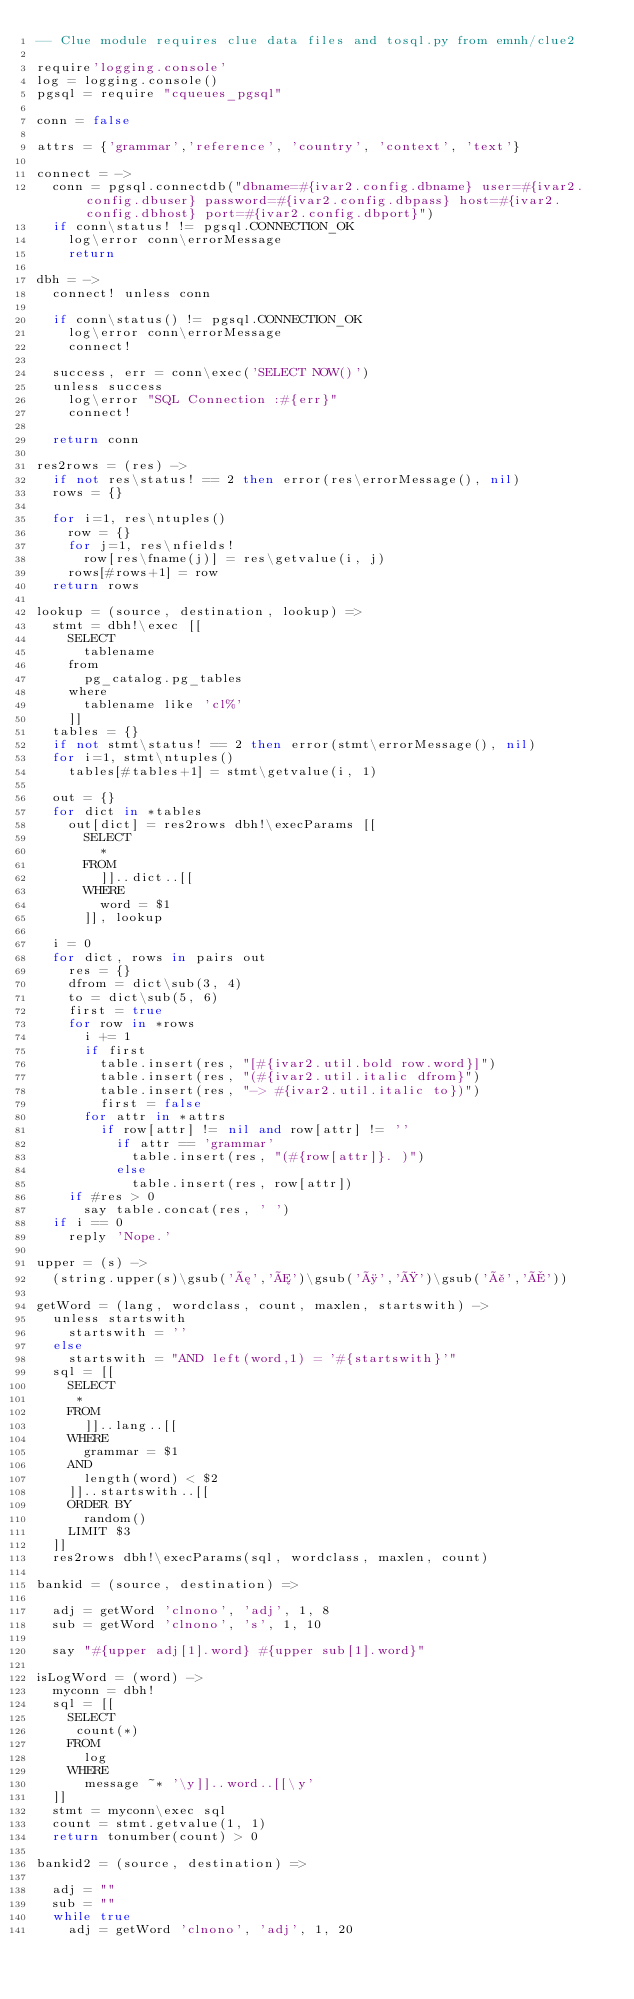Convert code to text. <code><loc_0><loc_0><loc_500><loc_500><_MoonScript_>-- Clue module requires clue data files and tosql.py from emnh/clue2

require'logging.console'
log = logging.console()
pgsql = require "cqueues_pgsql"

conn = false

attrs = {'grammar','reference', 'country', 'context', 'text'}

connect = ->
  conn = pgsql.connectdb("dbname=#{ivar2.config.dbname} user=#{ivar2.config.dbuser} password=#{ivar2.config.dbpass} host=#{ivar2.config.dbhost} port=#{ivar2.config.dbport}")
  if conn\status! != pgsql.CONNECTION_OK
    log\error conn\errorMessage
    return

dbh = ->
  connect! unless conn

  if conn\status() != pgsql.CONNECTION_OK
    log\error conn\errorMessage
    connect!

  success, err = conn\exec('SELECT NOW()')
  unless success
    log\error "SQL Connection :#{err}"
    connect!

  return conn

res2rows = (res) ->
  if not res\status! == 2 then error(res\errorMessage(), nil)
  rows = {}

  for i=1, res\ntuples()
    row = {}
    for j=1, res\nfields!
      row[res\fname(j)] = res\getvalue(i, j)
    rows[#rows+1] = row
  return rows

lookup = (source, destination, lookup) =>
  stmt = dbh!\exec [[
    SELECT
      tablename
    from
      pg_catalog.pg_tables
    where
      tablename like 'cl%'
    ]]
  tables = {}
  if not stmt\status! == 2 then error(stmt\errorMessage(), nil)
  for i=1, stmt\ntuples()
    tables[#tables+1] = stmt\getvalue(i, 1)

  out = {}
  for dict in *tables
    out[dict] = res2rows dbh!\execParams [[
      SELECT
        *
      FROM
        ]]..dict..[[
      WHERE
        word = $1
      ]], lookup

  i = 0
  for dict, rows in pairs out
    res = {}
    dfrom = dict\sub(3, 4)
    to = dict\sub(5, 6)
    first = true
    for row in *rows
      i += 1
      if first
        table.insert(res, "[#{ivar2.util.bold row.word}]")
        table.insert(res, "(#{ivar2.util.italic dfrom}")
        table.insert(res, "-> #{ivar2.util.italic to})")
        first = false
      for attr in *attrs
        if row[attr] != nil and row[attr] != ''
          if attr == 'grammar'
            table.insert(res, "(#{row[attr]}. )")
          else
            table.insert(res, row[attr])
    if #res > 0
      say table.concat(res, ' ')
  if i == 0
    reply 'Nope.'

upper = (s) ->
  (string.upper(s)\gsub('æ','Æ')\gsub('ø','Ø')\gsub('å','Å'))

getWord = (lang, wordclass, count, maxlen, startswith) ->
  unless startswith
    startswith = ''
  else
    startswith = "AND left(word,1) = '#{startswith}'"
  sql = [[
    SELECT
     *
    FROM
      ]]..lang..[[
    WHERE
      grammar = $1
    AND
      length(word) < $2
    ]]..startswith..[[
    ORDER BY
      random()
    LIMIT $3
  ]]
  res2rows dbh!\execParams(sql, wordclass, maxlen, count)

bankid = (source, destination) =>

  adj = getWord 'clnono', 'adj', 1, 8
  sub = getWord 'clnono', 's', 1, 10

  say "#{upper adj[1].word} #{upper sub[1].word}"

isLogWord = (word) ->
  myconn = dbh!
  sql = [[
    SELECT
     count(*)
    FROM
      log
    WHERE
      message ~* '\y]]..word..[[\y'
  ]]
  stmt = myconn\exec sql
  count = stmt.getvalue(1, 1)
  return tonumber(count) > 0

bankid2 = (source, destination) =>

  adj = ""
  sub = ""
  while true
    adj = getWord 'clnono', 'adj', 1, 20</code> 